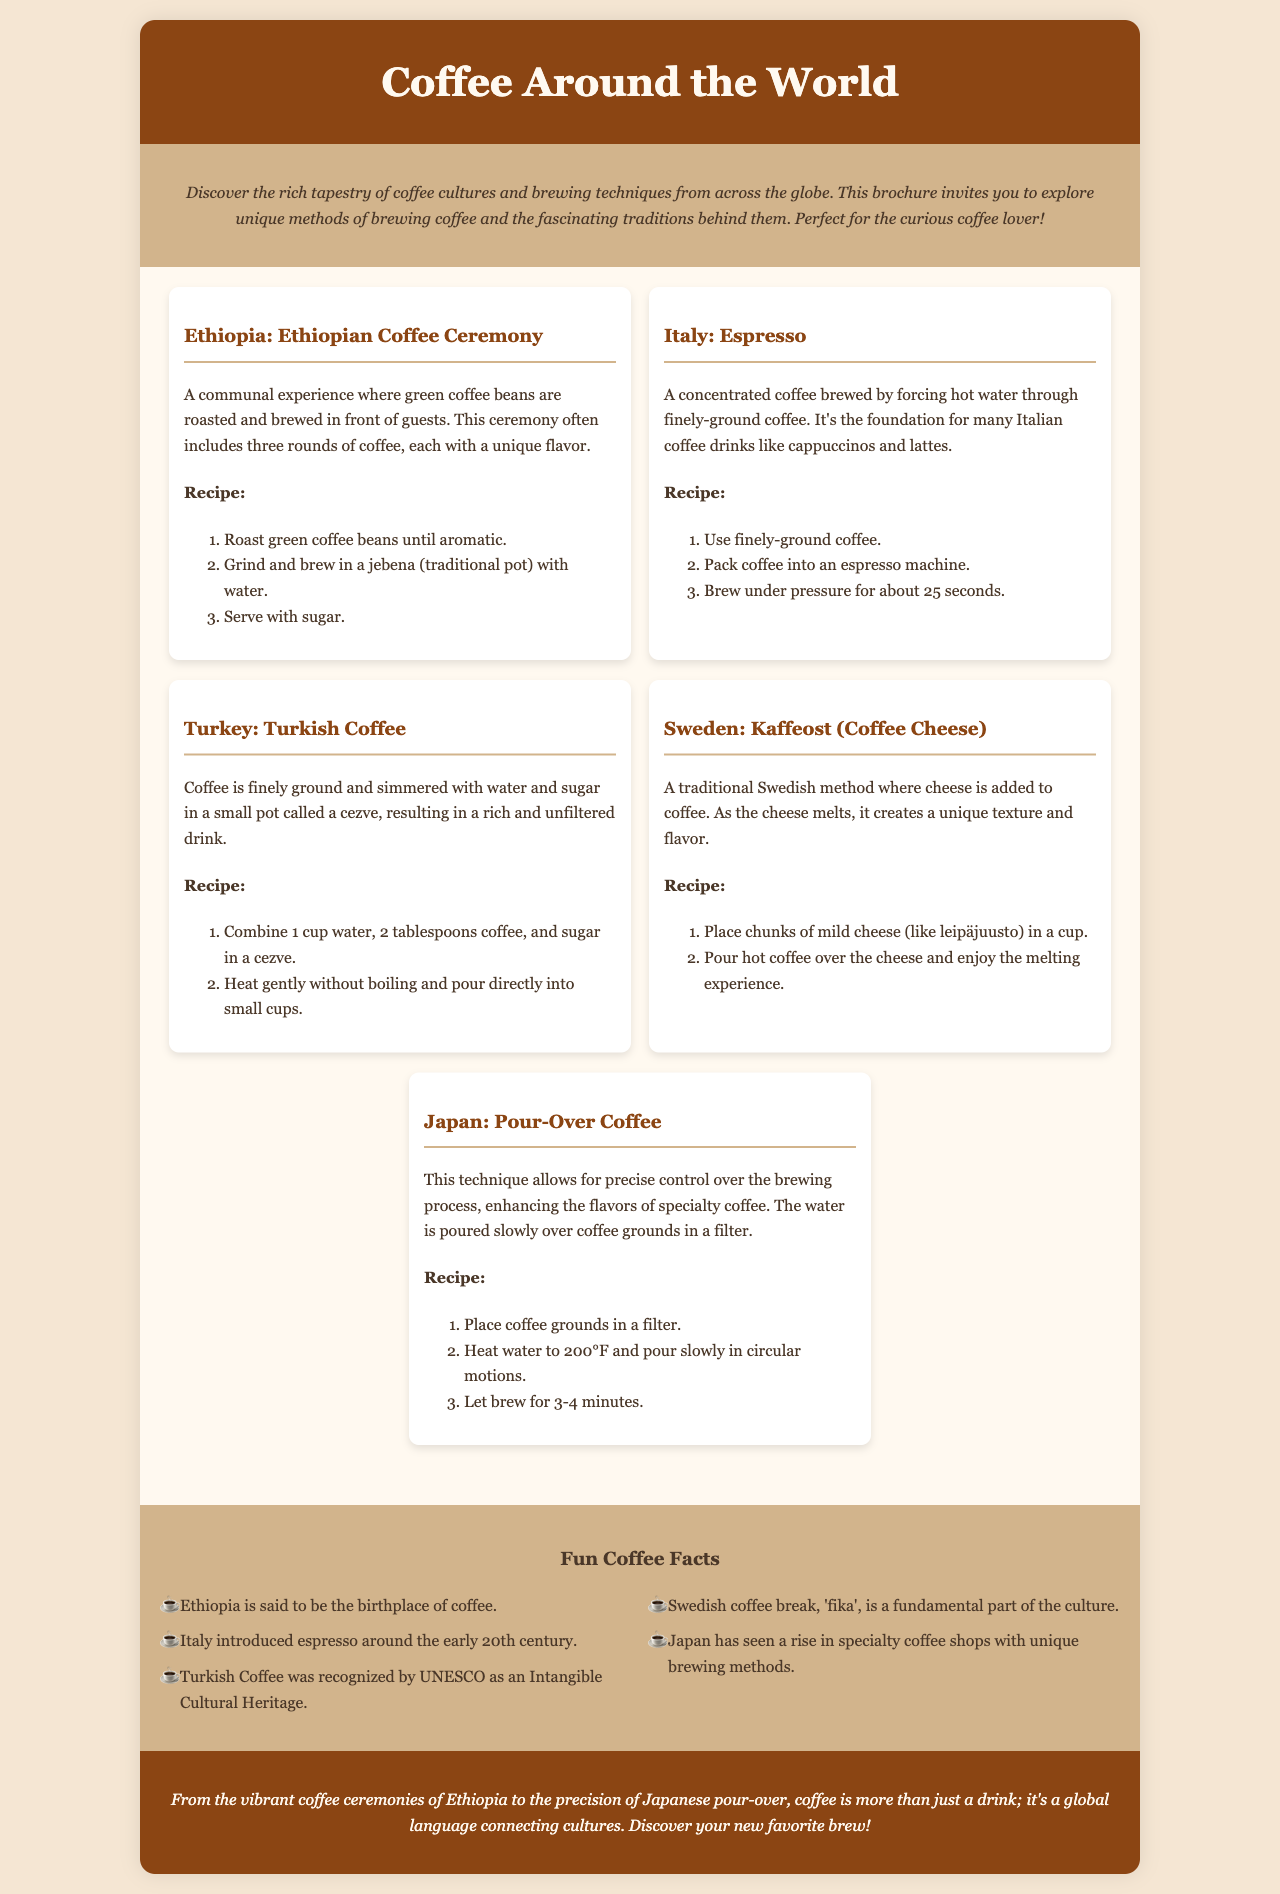what is the title of the brochure? The title is found in the header section at the top of the document.
Answer: Coffee Around the World what brewing technique is associated with Ethiopia? The information is presented in the coffee sections of the document under the Ethiopia entry.
Answer: Ethiopian Coffee Ceremony how many rounds of coffee are served in the Ethiopian coffee ceremony? The document specifies the number of coffee rounds mentioned in the Ethiopia section.
Answer: three what is the main ingredient in Turkish coffee? The Turkish coffee entry describes the main ingredient used in its preparation.
Answer: finely ground coffee which country is known for "fika"? The fun facts section highlights the cultural practice associated with a specific country.
Answer: Sweden what is the cooking method used for espresso? The Italy section explains the method of brewing espresso in detail.
Answer: forcing hot water which country has cheese added to coffee? The coffee sections list this unique method under a specific country's entry.
Answer: Sweden what type of coffee method enhances flavor through control? The document describes this method in the Japan section.
Answer: Pour-Over Coffee how many fun coffee facts are listed in the document? The number of entries in the fun facts section can be counted for the answer.
Answer: five 